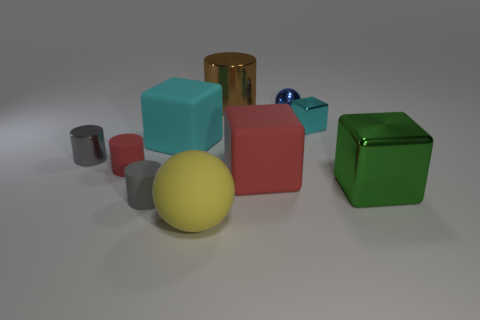Subtract all brown cylinders. How many cylinders are left? 3 Subtract all brown blocks. How many gray cylinders are left? 2 Subtract all spheres. How many objects are left? 8 Subtract 2 cubes. How many cubes are left? 2 Subtract all green cylinders. Subtract all cyan spheres. How many cylinders are left? 4 Subtract all red rubber balls. Subtract all large matte objects. How many objects are left? 7 Add 6 tiny shiny cylinders. How many tiny shiny cylinders are left? 7 Add 1 large blocks. How many large blocks exist? 4 Subtract all red cylinders. How many cylinders are left? 3 Subtract 0 blue blocks. How many objects are left? 10 